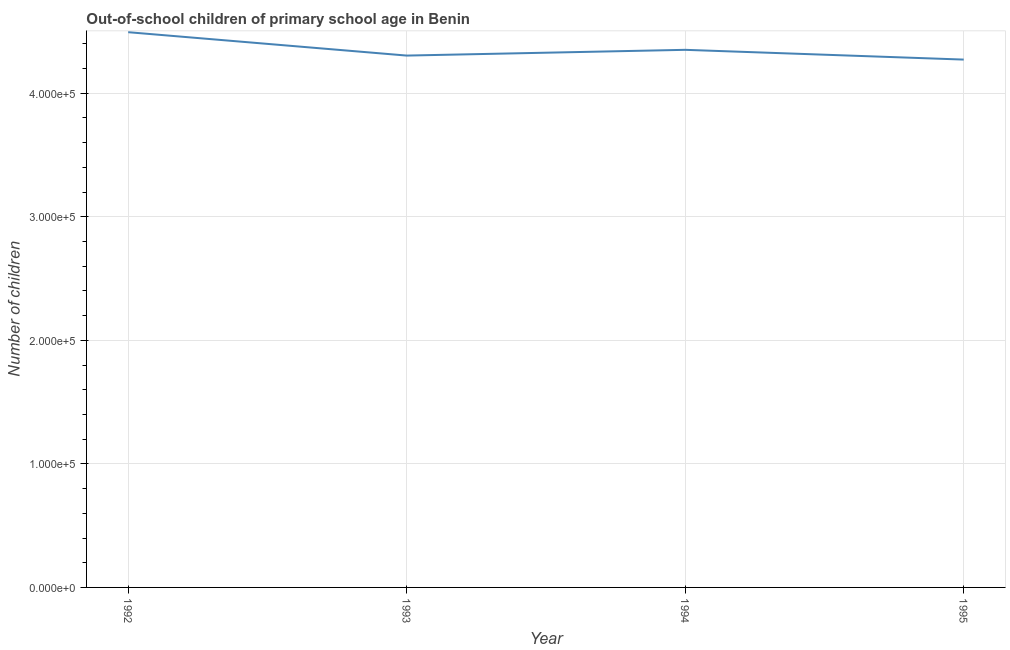What is the number of out-of-school children in 1993?
Your response must be concise. 4.30e+05. Across all years, what is the maximum number of out-of-school children?
Your answer should be compact. 4.49e+05. Across all years, what is the minimum number of out-of-school children?
Offer a very short reply. 4.27e+05. In which year was the number of out-of-school children maximum?
Offer a terse response. 1992. What is the sum of the number of out-of-school children?
Provide a short and direct response. 1.74e+06. What is the difference between the number of out-of-school children in 1994 and 1995?
Offer a very short reply. 7897. What is the average number of out-of-school children per year?
Your answer should be compact. 4.36e+05. What is the median number of out-of-school children?
Ensure brevity in your answer.  4.33e+05. In how many years, is the number of out-of-school children greater than 60000 ?
Your answer should be compact. 4. Do a majority of the years between 1995 and 1992 (inclusive) have number of out-of-school children greater than 80000 ?
Provide a succinct answer. Yes. What is the ratio of the number of out-of-school children in 1993 to that in 1994?
Offer a terse response. 0.99. What is the difference between the highest and the second highest number of out-of-school children?
Keep it short and to the point. 1.43e+04. Is the sum of the number of out-of-school children in 1994 and 1995 greater than the maximum number of out-of-school children across all years?
Make the answer very short. Yes. What is the difference between the highest and the lowest number of out-of-school children?
Make the answer very short. 2.22e+04. What is the difference between two consecutive major ticks on the Y-axis?
Keep it short and to the point. 1.00e+05. Does the graph contain any zero values?
Your answer should be compact. No. What is the title of the graph?
Offer a terse response. Out-of-school children of primary school age in Benin. What is the label or title of the X-axis?
Provide a short and direct response. Year. What is the label or title of the Y-axis?
Provide a succinct answer. Number of children. What is the Number of children in 1992?
Offer a terse response. 4.49e+05. What is the Number of children in 1993?
Offer a terse response. 4.30e+05. What is the Number of children of 1994?
Your answer should be very brief. 4.35e+05. What is the Number of children in 1995?
Offer a terse response. 4.27e+05. What is the difference between the Number of children in 1992 and 1993?
Give a very brief answer. 1.89e+04. What is the difference between the Number of children in 1992 and 1994?
Offer a very short reply. 1.43e+04. What is the difference between the Number of children in 1992 and 1995?
Keep it short and to the point. 2.22e+04. What is the difference between the Number of children in 1993 and 1994?
Your answer should be very brief. -4653. What is the difference between the Number of children in 1993 and 1995?
Give a very brief answer. 3244. What is the difference between the Number of children in 1994 and 1995?
Provide a short and direct response. 7897. What is the ratio of the Number of children in 1992 to that in 1993?
Make the answer very short. 1.04. What is the ratio of the Number of children in 1992 to that in 1994?
Offer a terse response. 1.03. What is the ratio of the Number of children in 1992 to that in 1995?
Your answer should be compact. 1.05. 